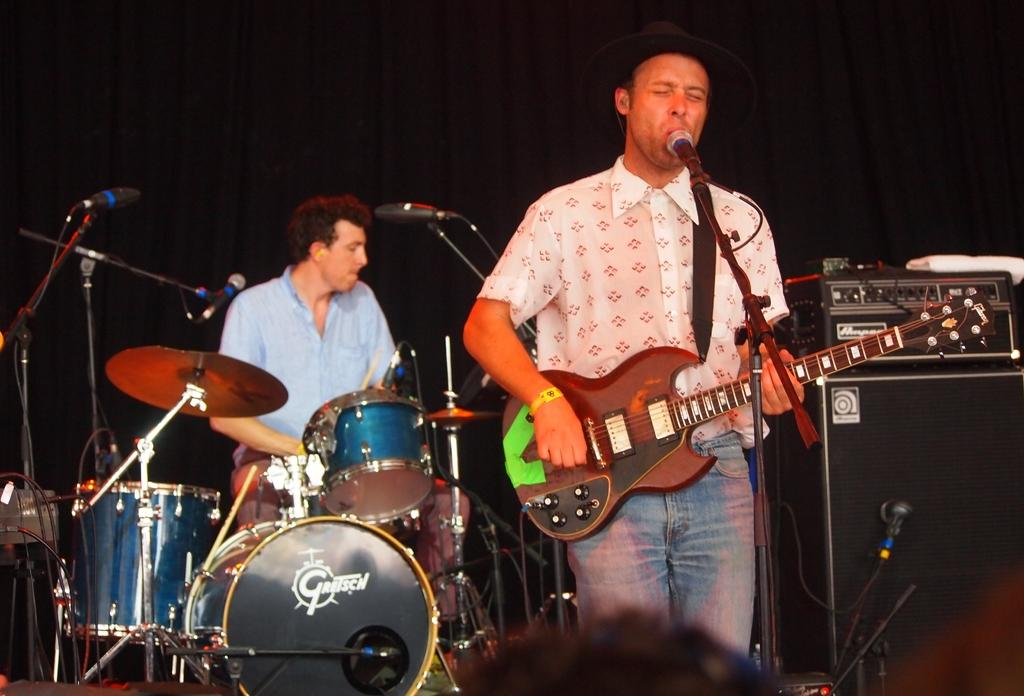How many people are in the image? There are people in the image. What are the people doing in the image? The people are playing musical instruments. How many sheep can be seen grazing in the background of the image? There are no sheep present in the image; it features people playing musical instruments. What religious belief do the people in the image adhere to? There is no information about the people's religious beliefs in the image. 